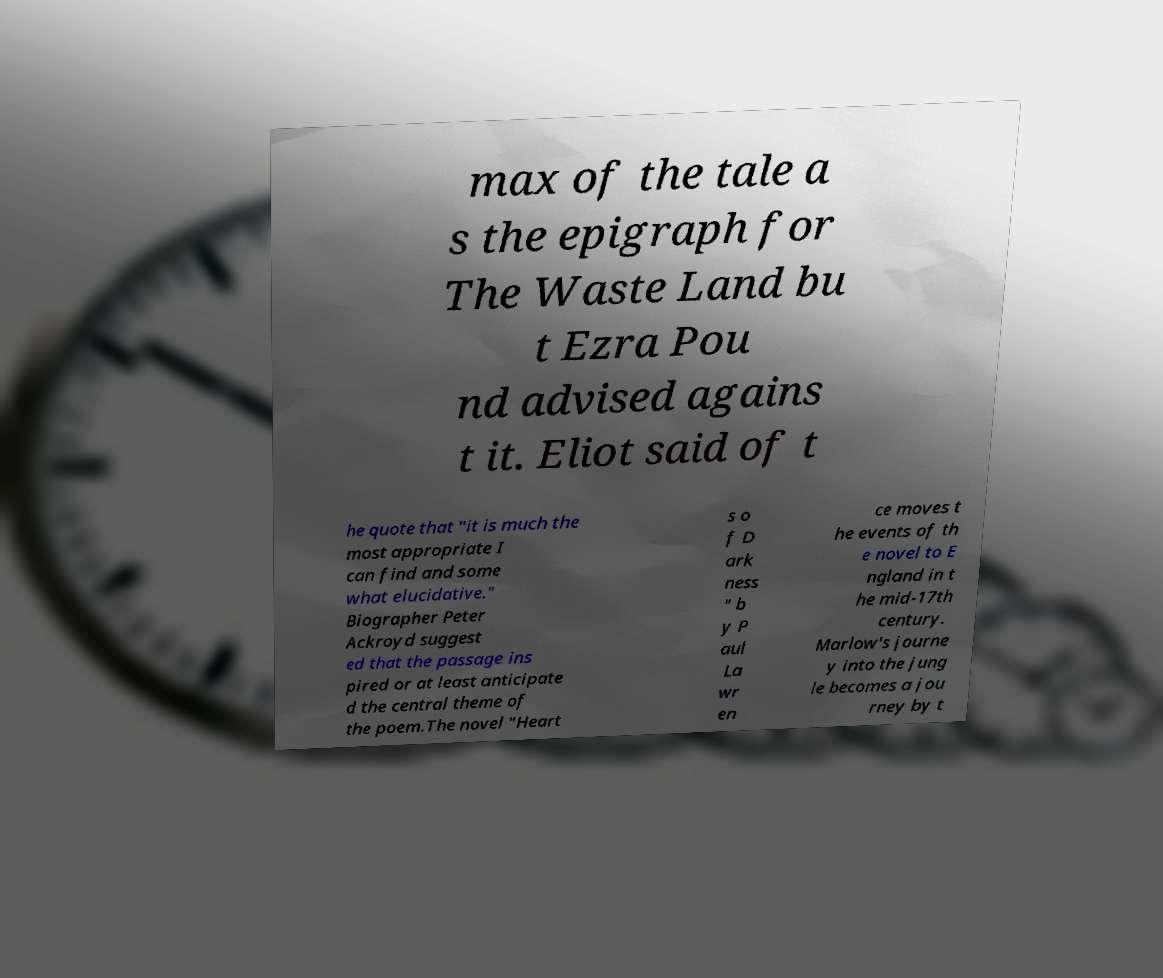Can you accurately transcribe the text from the provided image for me? max of the tale a s the epigraph for The Waste Land bu t Ezra Pou nd advised agains t it. Eliot said of t he quote that "it is much the most appropriate I can find and some what elucidative." Biographer Peter Ackroyd suggest ed that the passage ins pired or at least anticipate d the central theme of the poem.The novel "Heart s o f D ark ness " b y P aul La wr en ce moves t he events of th e novel to E ngland in t he mid-17th century. Marlow's journe y into the jung le becomes a jou rney by t 